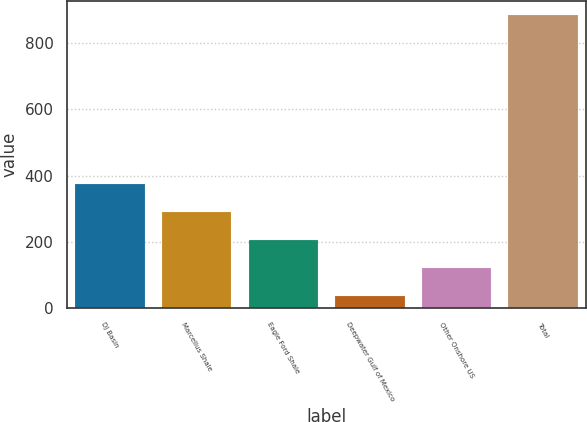Convert chart to OTSL. <chart><loc_0><loc_0><loc_500><loc_500><bar_chart><fcel>DJ Basin<fcel>Marcellus Shale<fcel>Eagle Ford Shale<fcel>Deepwater Gulf of Mexico<fcel>Other Onshore US<fcel>Total<nl><fcel>375.2<fcel>290.4<fcel>205.6<fcel>36<fcel>120.8<fcel>884<nl></chart> 